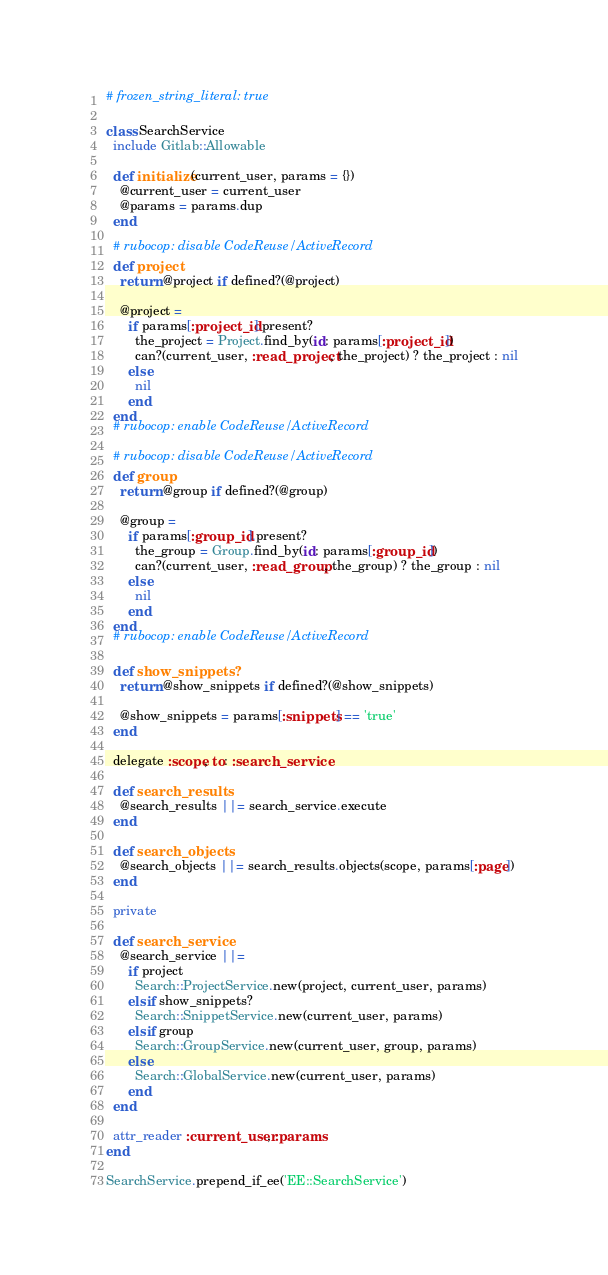Convert code to text. <code><loc_0><loc_0><loc_500><loc_500><_Ruby_># frozen_string_literal: true

class SearchService
  include Gitlab::Allowable

  def initialize(current_user, params = {})
    @current_user = current_user
    @params = params.dup
  end

  # rubocop: disable CodeReuse/ActiveRecord
  def project
    return @project if defined?(@project)

    @project =
      if params[:project_id].present?
        the_project = Project.find_by(id: params[:project_id])
        can?(current_user, :read_project, the_project) ? the_project : nil
      else
        nil
      end
  end
  # rubocop: enable CodeReuse/ActiveRecord

  # rubocop: disable CodeReuse/ActiveRecord
  def group
    return @group if defined?(@group)

    @group =
      if params[:group_id].present?
        the_group = Group.find_by(id: params[:group_id])
        can?(current_user, :read_group, the_group) ? the_group : nil
      else
        nil
      end
  end
  # rubocop: enable CodeReuse/ActiveRecord

  def show_snippets?
    return @show_snippets if defined?(@show_snippets)

    @show_snippets = params[:snippets] == 'true'
  end

  delegate :scope, to: :search_service

  def search_results
    @search_results ||= search_service.execute
  end

  def search_objects
    @search_objects ||= search_results.objects(scope, params[:page])
  end

  private

  def search_service
    @search_service ||=
      if project
        Search::ProjectService.new(project, current_user, params)
      elsif show_snippets?
        Search::SnippetService.new(current_user, params)
      elsif group
        Search::GroupService.new(current_user, group, params)
      else
        Search::GlobalService.new(current_user, params)
      end
  end

  attr_reader :current_user, :params
end

SearchService.prepend_if_ee('EE::SearchService')
</code> 